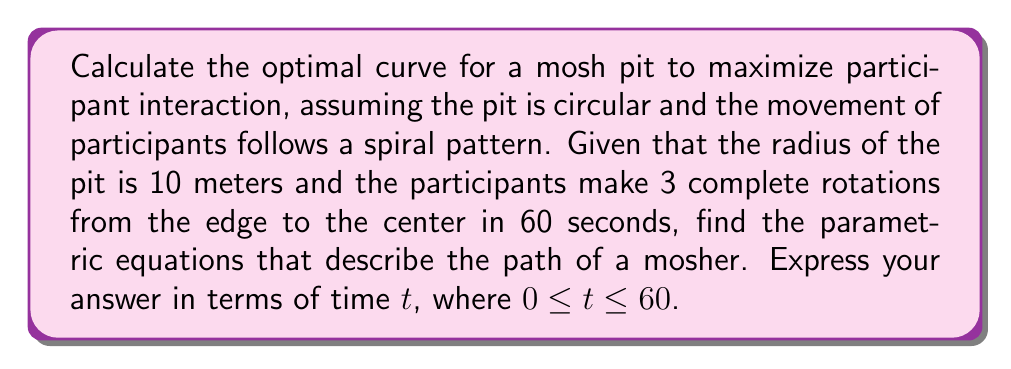Can you solve this math problem? To solve this problem, we'll use parametric equations to describe the spiral path of a mosher in the circular mosh pit. Let's break it down step-by-step:

1) First, we need to recognize that this is a spiral motion in a circular area. The best way to represent this is using polar coordinates, which we'll then convert to parametric form.

2) In polar form, a spiral is generally represented as:
   $$r = a - bt$$
   where r is the radius, a is the starting radius, b is the rate of spiral, and t is time.

3) We know that:
   - The starting radius (a) is 10 meters
   - The ending radius is 0 (center of the pit)
   - The time taken is 60 seconds

4) Using these, we can find b:
   $$0 = 10 - 60b$$
   $$60b = 10$$
   $$b = \frac{1}{6}$$

5) So our polar equation is:
   $$r = 10 - \frac{1}{6}t$$

6) To convert this to parametric form, we use the following conversions:
   $$x = r \cos(\theta)$$
   $$y = r \sin(\theta)$$

7) We need to express θ in terms of t. Since the mosher makes 3 complete rotations in 60 seconds:
   $$\theta = 3 \cdot 2\pi \cdot \frac{t}{60} = \frac{\pi t}{10}$$

8) Substituting these into our parametric equations:
   $$x = (10 - \frac{1}{6}t) \cos(\frac{\pi t}{10})$$
   $$y = (10 - \frac{1}{6}t) \sin(\frac{\pi t}{10})$$

These parametric equations describe the optimal curve for a mosher in the pit, maximizing interaction as they spiral from the edge to the center.
Answer: The parametric equations describing the optimal path of a mosher are:

$$x = (10 - \frac{1}{6}t) \cos(\frac{\pi t}{10})$$
$$y = (10 - \frac{1}{6}t) \sin(\frac{\pi t}{10})$$

where 0 ≤ t ≤ 60. 